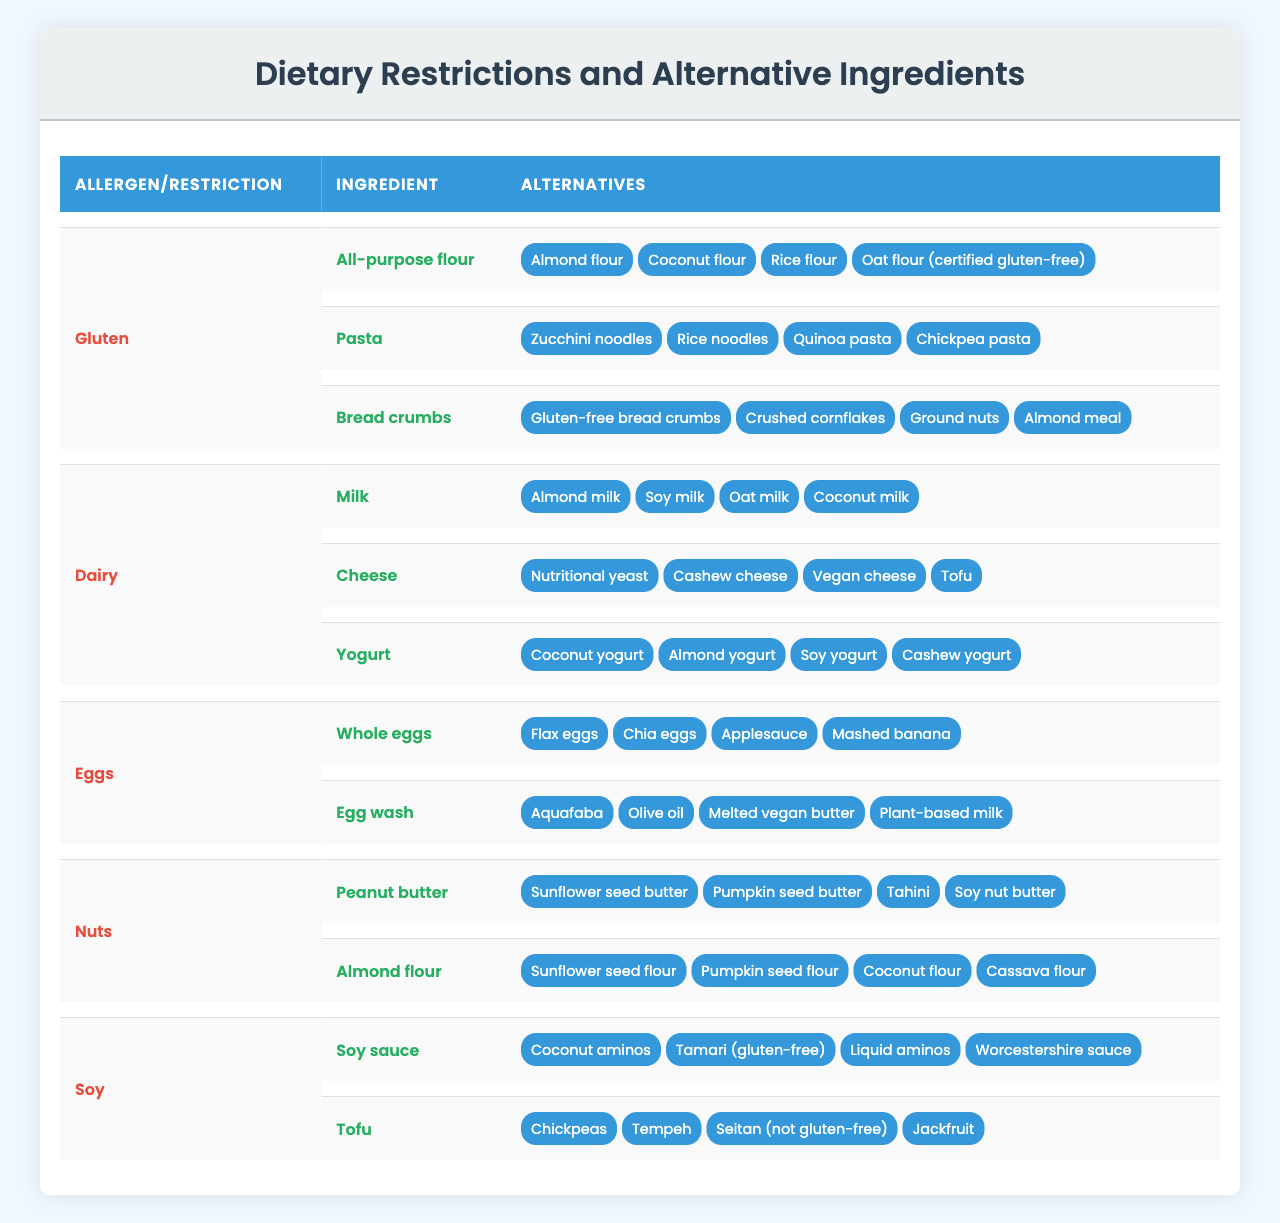What are the alternative ingredients for gluten in pasta? According to the table, gluten alternatives for pasta include zucchini noodles, rice noodles, quinoa pasta, and chickpea pasta.
Answer: Zucchini noodles, rice noodles, quinoa pasta, chickpea pasta Is almond milk a good alternative for regular milk for those with a dairy restriction? Yes, almond milk is listed as an alternative to regular milk in the dairy restrictions section of the table.
Answer: Yes How many alternatives are provided for whole eggs? The table shows that four alternatives are provided for whole eggs: flax eggs, chia eggs, applesauce, and mashed banana.
Answer: Four alternatives Which allergen has the most alternative ingredients listed? By counting the alternatives for each allergen, dairy has the most alternatives listed with a total of 12 (4 for milk, 4 for cheese, and 4 for yogurt).
Answer: Dairy Are there any alternatives listed for eggs used as an egg wash? Yes, the table includes four alternatives for egg wash: aquafaba, olive oil, melted vegan butter, and plant-based milk.
Answer: Yes What is the difference between the number of alternatives for peanut butter and for whole eggs? Peanut butter has four alternatives listed, while whole eggs also have four alternatives, hence the difference is 0.
Answer: 0 Can coconut aminos be used as a substitute for soy sauce? Yes, the table indicates that coconut aminos are an alternative ingredient for soy sauce, making it a suitable substitute.
Answer: Yes Sum the total number of alternative ingredients for all allergens that contain bread-related items. For gluten: there are 4 alternatives for bread crumbs. For dairy, there are no bread alternatives. The total is 4.
Answer: 4 Is it true that all alternatives for almond flour are gluten-free? Yes, the alternatives for almond flour listed in the table (sunflower seed flour, pumpkin seed flour, coconut flour, cassava flour) are all gluten-free.
Answer: Yes List any two alternatives for cheese that are dairy-free. The alternatives for cheese include nutritional yeast and cashew cheese, both of which are dairy-free options.
Answer: Nutritional yeast, cashew cheese 